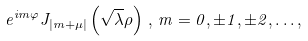Convert formula to latex. <formula><loc_0><loc_0><loc_500><loc_500>e ^ { i m \varphi } J _ { \left | m + \mu \right | } \left ( \sqrt { \lambda } \rho \right ) \, , \, m = 0 , \pm 1 , \pm 2 , \dots ,</formula> 